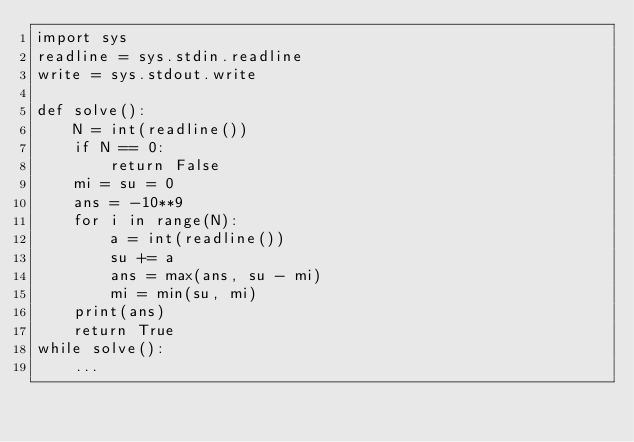Convert code to text. <code><loc_0><loc_0><loc_500><loc_500><_Python_>import sys
readline = sys.stdin.readline
write = sys.stdout.write

def solve():
    N = int(readline())
    if N == 0:
        return False
    mi = su = 0
    ans = -10**9
    for i in range(N):
        a = int(readline())
        su += a
        ans = max(ans, su - mi)
        mi = min(su, mi)
    print(ans)
    return True
while solve():
    ...

</code> 